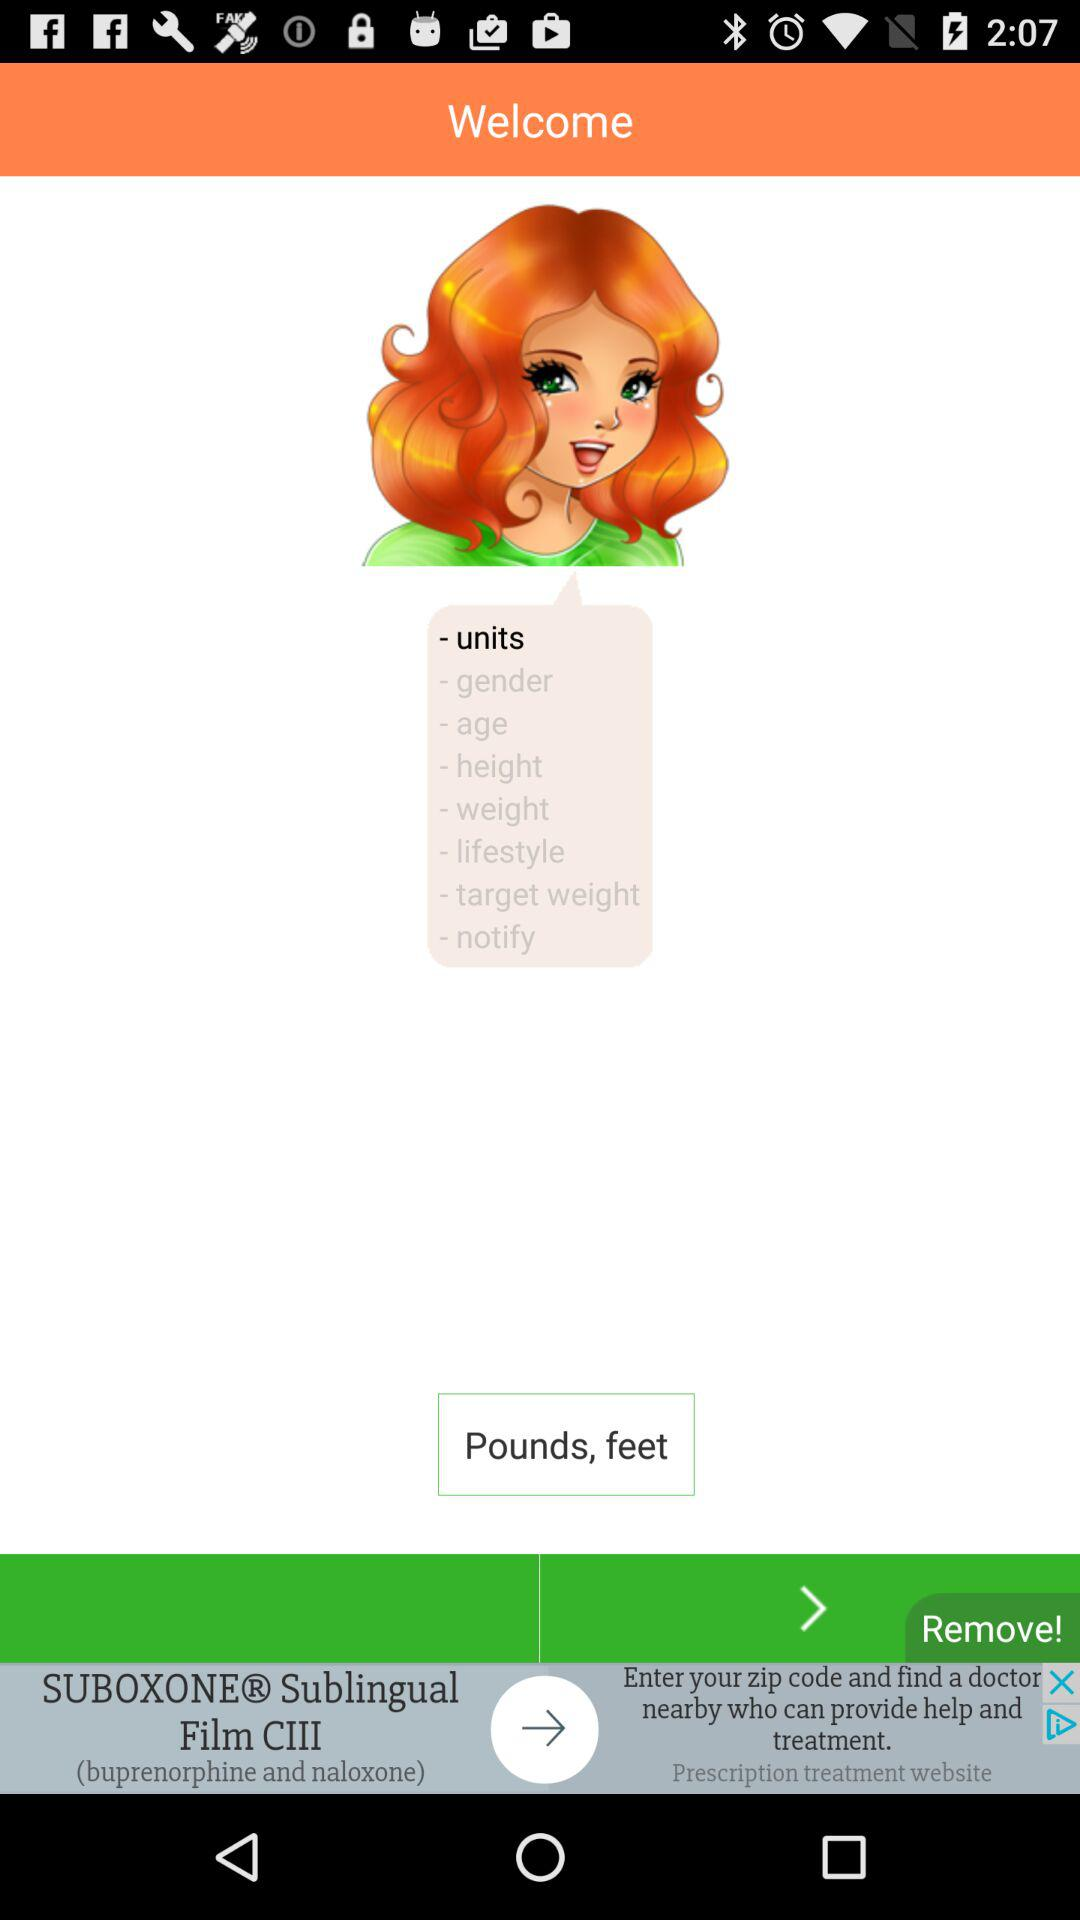Which option is selected? The selected option is "units". 